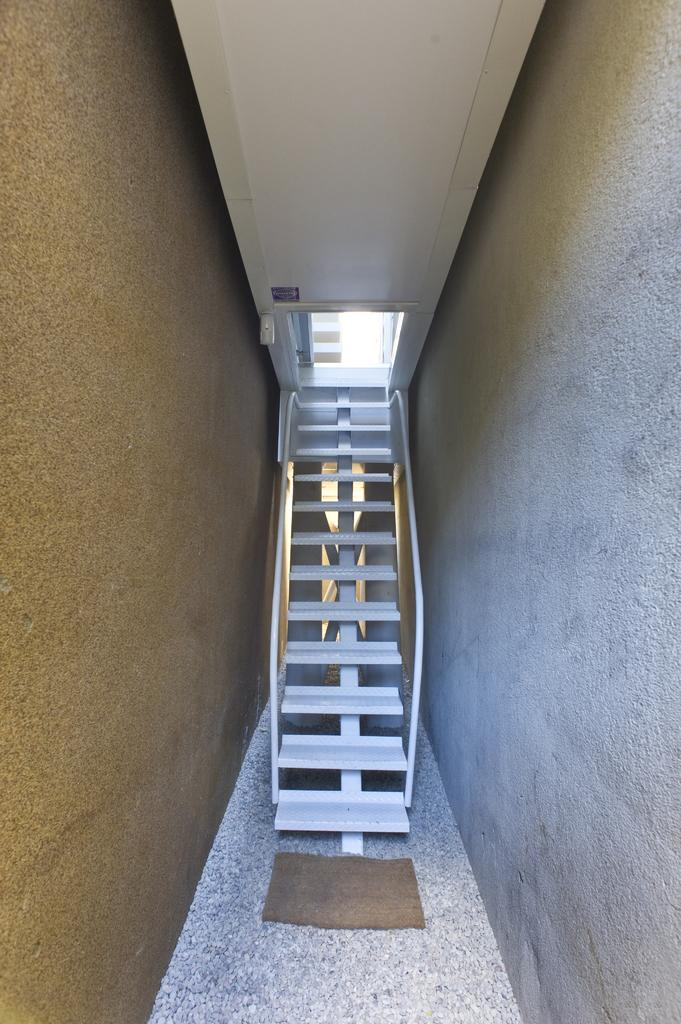What type of architectural feature is present in the image? There are stairs in the image. What can be seen in the background of the image? There is a wall in the background of the image. What type of exchange is taking place between the father and son in the image? There is no father or son present in the image, and therefore no exchange can be observed. 